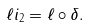<formula> <loc_0><loc_0><loc_500><loc_500>\ell i _ { 2 } = \ell \circ \delta .</formula> 